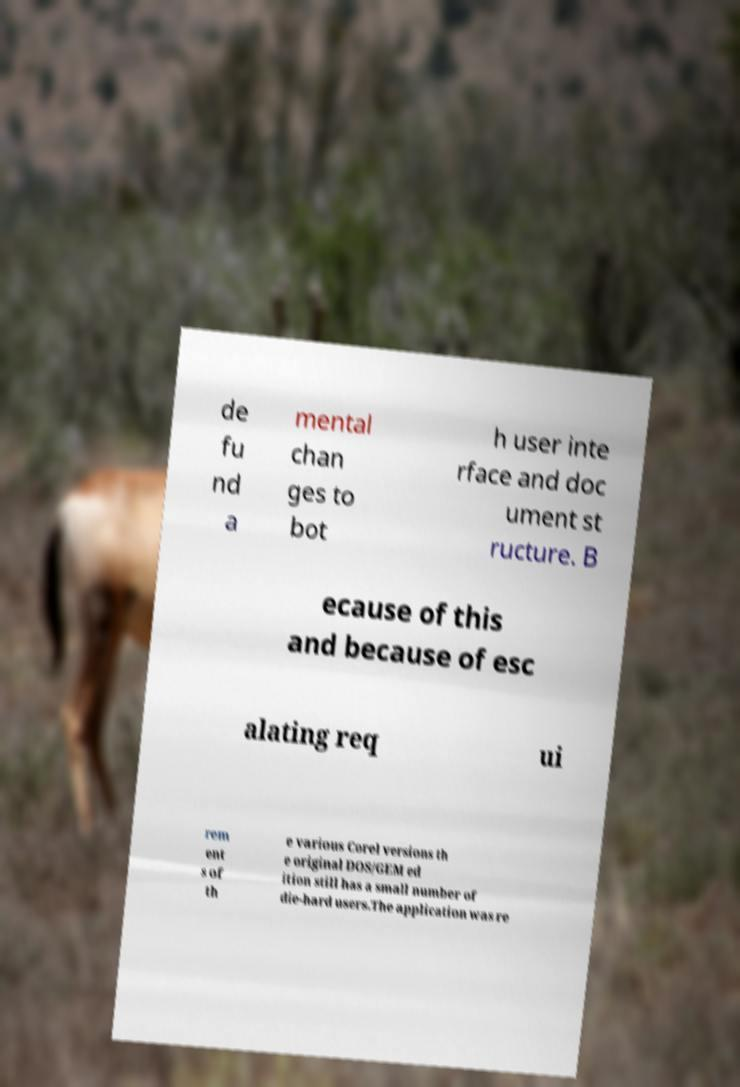For documentation purposes, I need the text within this image transcribed. Could you provide that? de fu nd a mental chan ges to bot h user inte rface and doc ument st ructure. B ecause of this and because of esc alating req ui rem ent s of th e various Corel versions th e original DOS/GEM ed ition still has a small number of die-hard users.The application was re 